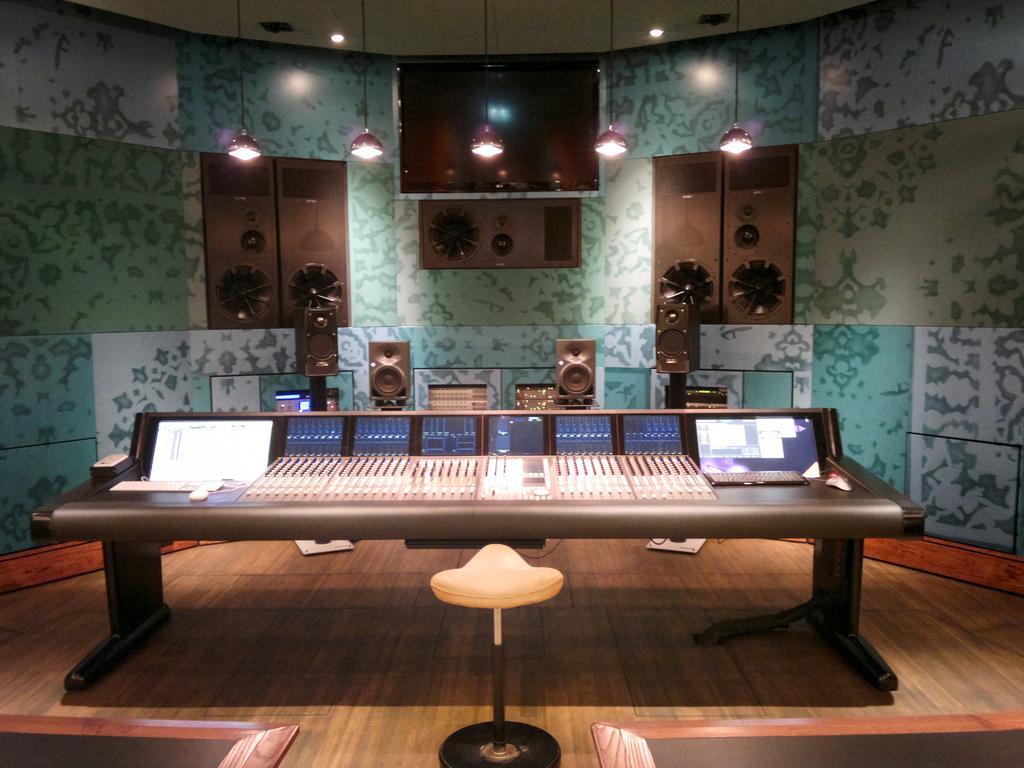Please provide a concise description of this image. In this picture we can see a music system and a chair on the floor. Behind the music system, there are speakers and on the wall there are some objects. At the top there are ceiling lights and some lights are hanged to the ceiling. 